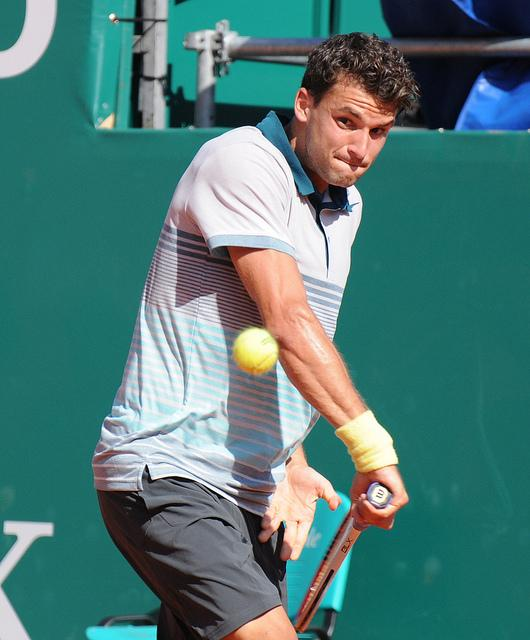What manner will the person here hit the ball?

Choices:
A) forehanded
B) head butt
C) two handed
D) backhanded backhanded 